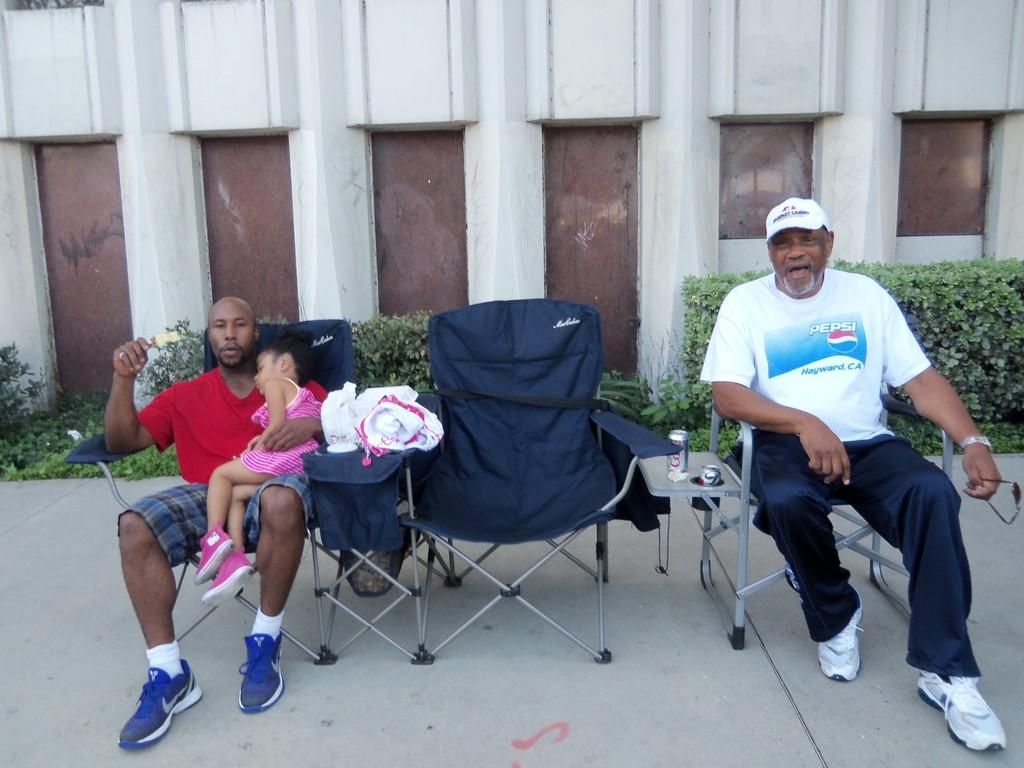How many people are present in the image? There are two men and a girl in the image. What is the girl doing in the image? The girl is seated in the image. On what is the girl seated? The girl is seated on a chair. What can be seen in the background of the image? There are plants visible in the image, located behind the people. What type of receipt can be seen in the girl's hand in the image? There is no receipt present in the image; the girl is not holding anything. Can you tell me the relationship between the girl and the two men in the image? The provided facts do not specify the relationship between the girl and the two men. 